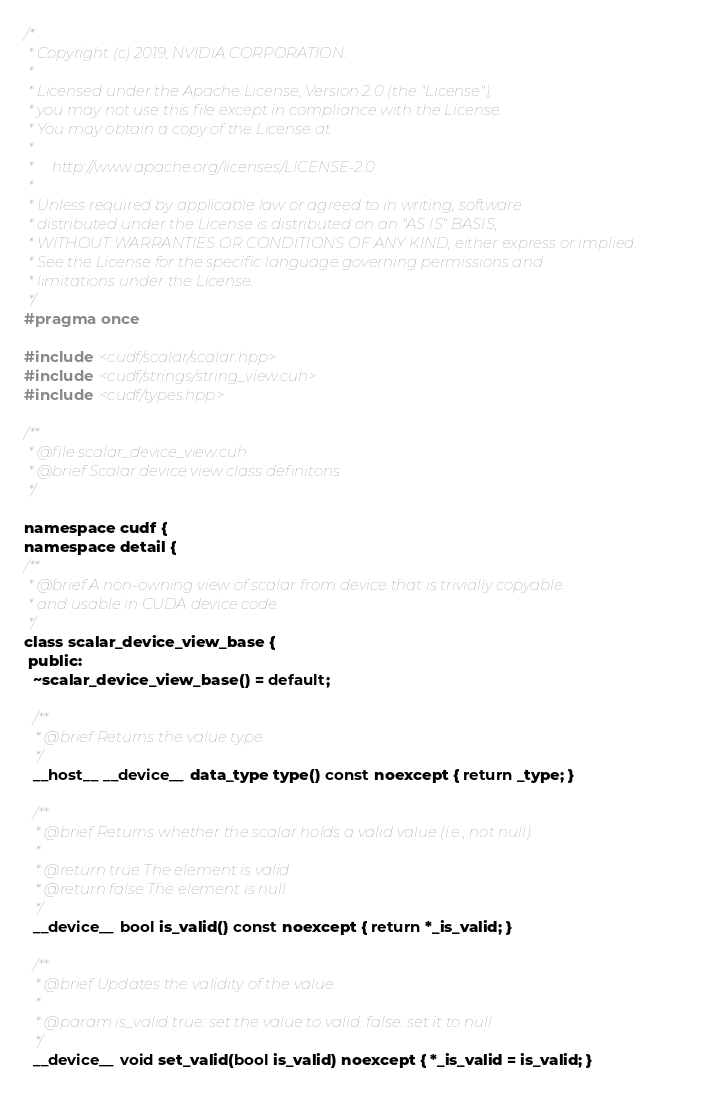<code> <loc_0><loc_0><loc_500><loc_500><_Cuda_>/*
 * Copyright (c) 2019, NVIDIA CORPORATION.
 *
 * Licensed under the Apache License, Version 2.0 (the "License");
 * you may not use this file except in compliance with the License.
 * You may obtain a copy of the License at
 *
 *     http://www.apache.org/licenses/LICENSE-2.0
 *
 * Unless required by applicable law or agreed to in writing, software
 * distributed under the License is distributed on an "AS IS" BASIS,
 * WITHOUT WARRANTIES OR CONDITIONS OF ANY KIND, either express or implied.
 * See the License for the specific language governing permissions and
 * limitations under the License.
 */
#pragma once

#include <cudf/scalar/scalar.hpp>
#include <cudf/strings/string_view.cuh>
#include <cudf/types.hpp>

/**
 * @file scalar_device_view.cuh
 * @brief Scalar device view class definitons
 */

namespace cudf {
namespace detail {
/**
 * @brief A non-owning view of scalar from device that is trivially copyable
 * and usable in CUDA device code.
 */
class scalar_device_view_base {
 public:
  ~scalar_device_view_base() = default;

  /**
   * @brief Returns the value type
   */
  __host__ __device__ data_type type() const noexcept { return _type; }

  /**
   * @brief Returns whether the scalar holds a valid value (i.e., not null).
   *
   * @return true The element is valid
   * @return false The element is null
   */
  __device__ bool is_valid() const noexcept { return *_is_valid; }

  /**
   * @brief Updates the validity of the value
   *
   * @param is_valid true: set the value to valid. false: set it to null
   */
  __device__ void set_valid(bool is_valid) noexcept { *_is_valid = is_valid; }
</code> 